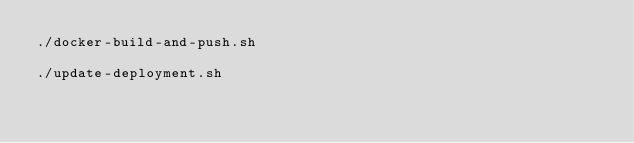<code> <loc_0><loc_0><loc_500><loc_500><_Bash_>./docker-build-and-push.sh

./update-deployment.sh</code> 